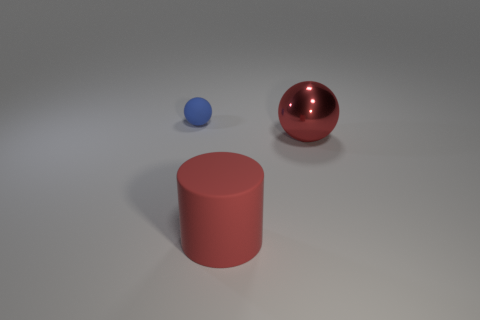There is a small blue rubber object; what shape is it?
Ensure brevity in your answer.  Sphere. There is a big object that is in front of the red ball; is it the same color as the metal sphere?
Make the answer very short. Yes. There is a thing that is in front of the blue thing and to the left of the red ball; what shape is it?
Keep it short and to the point. Cylinder. There is a matte thing that is to the left of the large red cylinder; what color is it?
Make the answer very short. Blue. Are there any other things of the same color as the shiny object?
Give a very brief answer. Yes. Is the metal ball the same size as the red cylinder?
Offer a very short reply. Yes. There is a thing that is behind the red matte object and right of the matte sphere; what is its size?
Ensure brevity in your answer.  Large. How many balls are the same material as the cylinder?
Keep it short and to the point. 1. There is a large thing that is the same color as the metal sphere; what shape is it?
Provide a short and direct response. Cylinder. The big metallic ball is what color?
Keep it short and to the point. Red. 